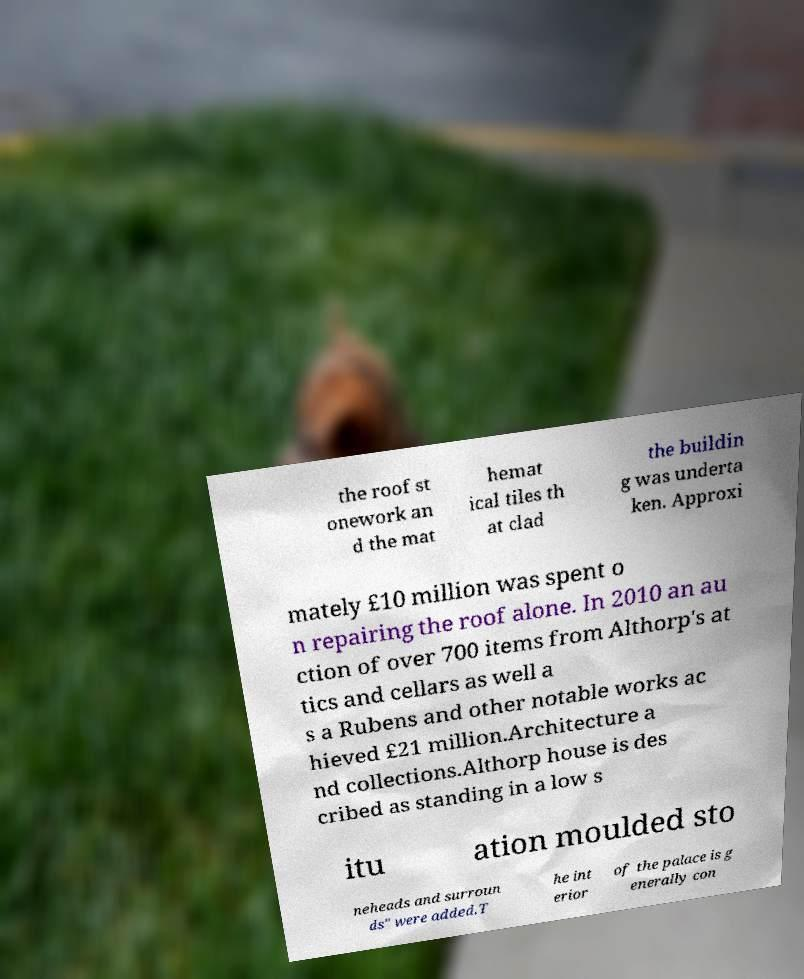For documentation purposes, I need the text within this image transcribed. Could you provide that? the roof st onework an d the mat hemat ical tiles th at clad the buildin g was underta ken. Approxi mately £10 million was spent o n repairing the roof alone. In 2010 an au ction of over 700 items from Althorp's at tics and cellars as well a s a Rubens and other notable works ac hieved £21 million.Architecture a nd collections.Althorp house is des cribed as standing in a low s itu ation moulded sto neheads and surroun ds" were added.T he int erior of the palace is g enerally con 